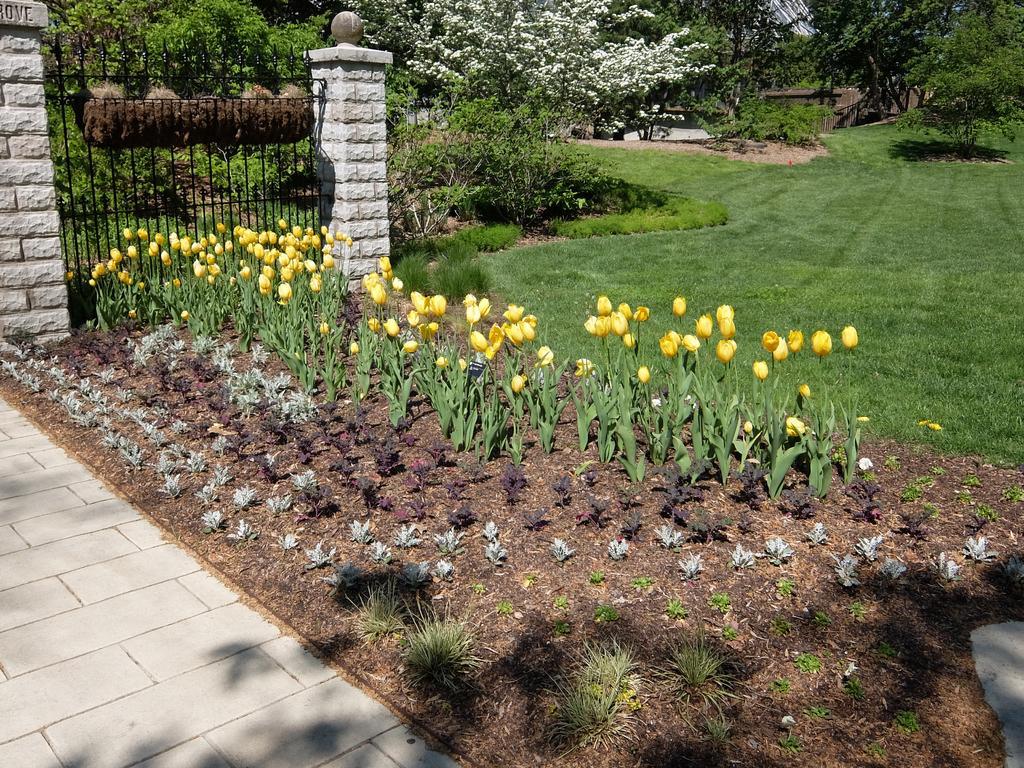Can you describe this image briefly? In the image the land is covered with flower plants,grass and trees, on the left side there is a fence. 